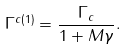Convert formula to latex. <formula><loc_0><loc_0><loc_500><loc_500>\Gamma ^ { c ( 1 ) } = \frac { \Gamma _ { c } } { 1 + M \gamma } .</formula> 